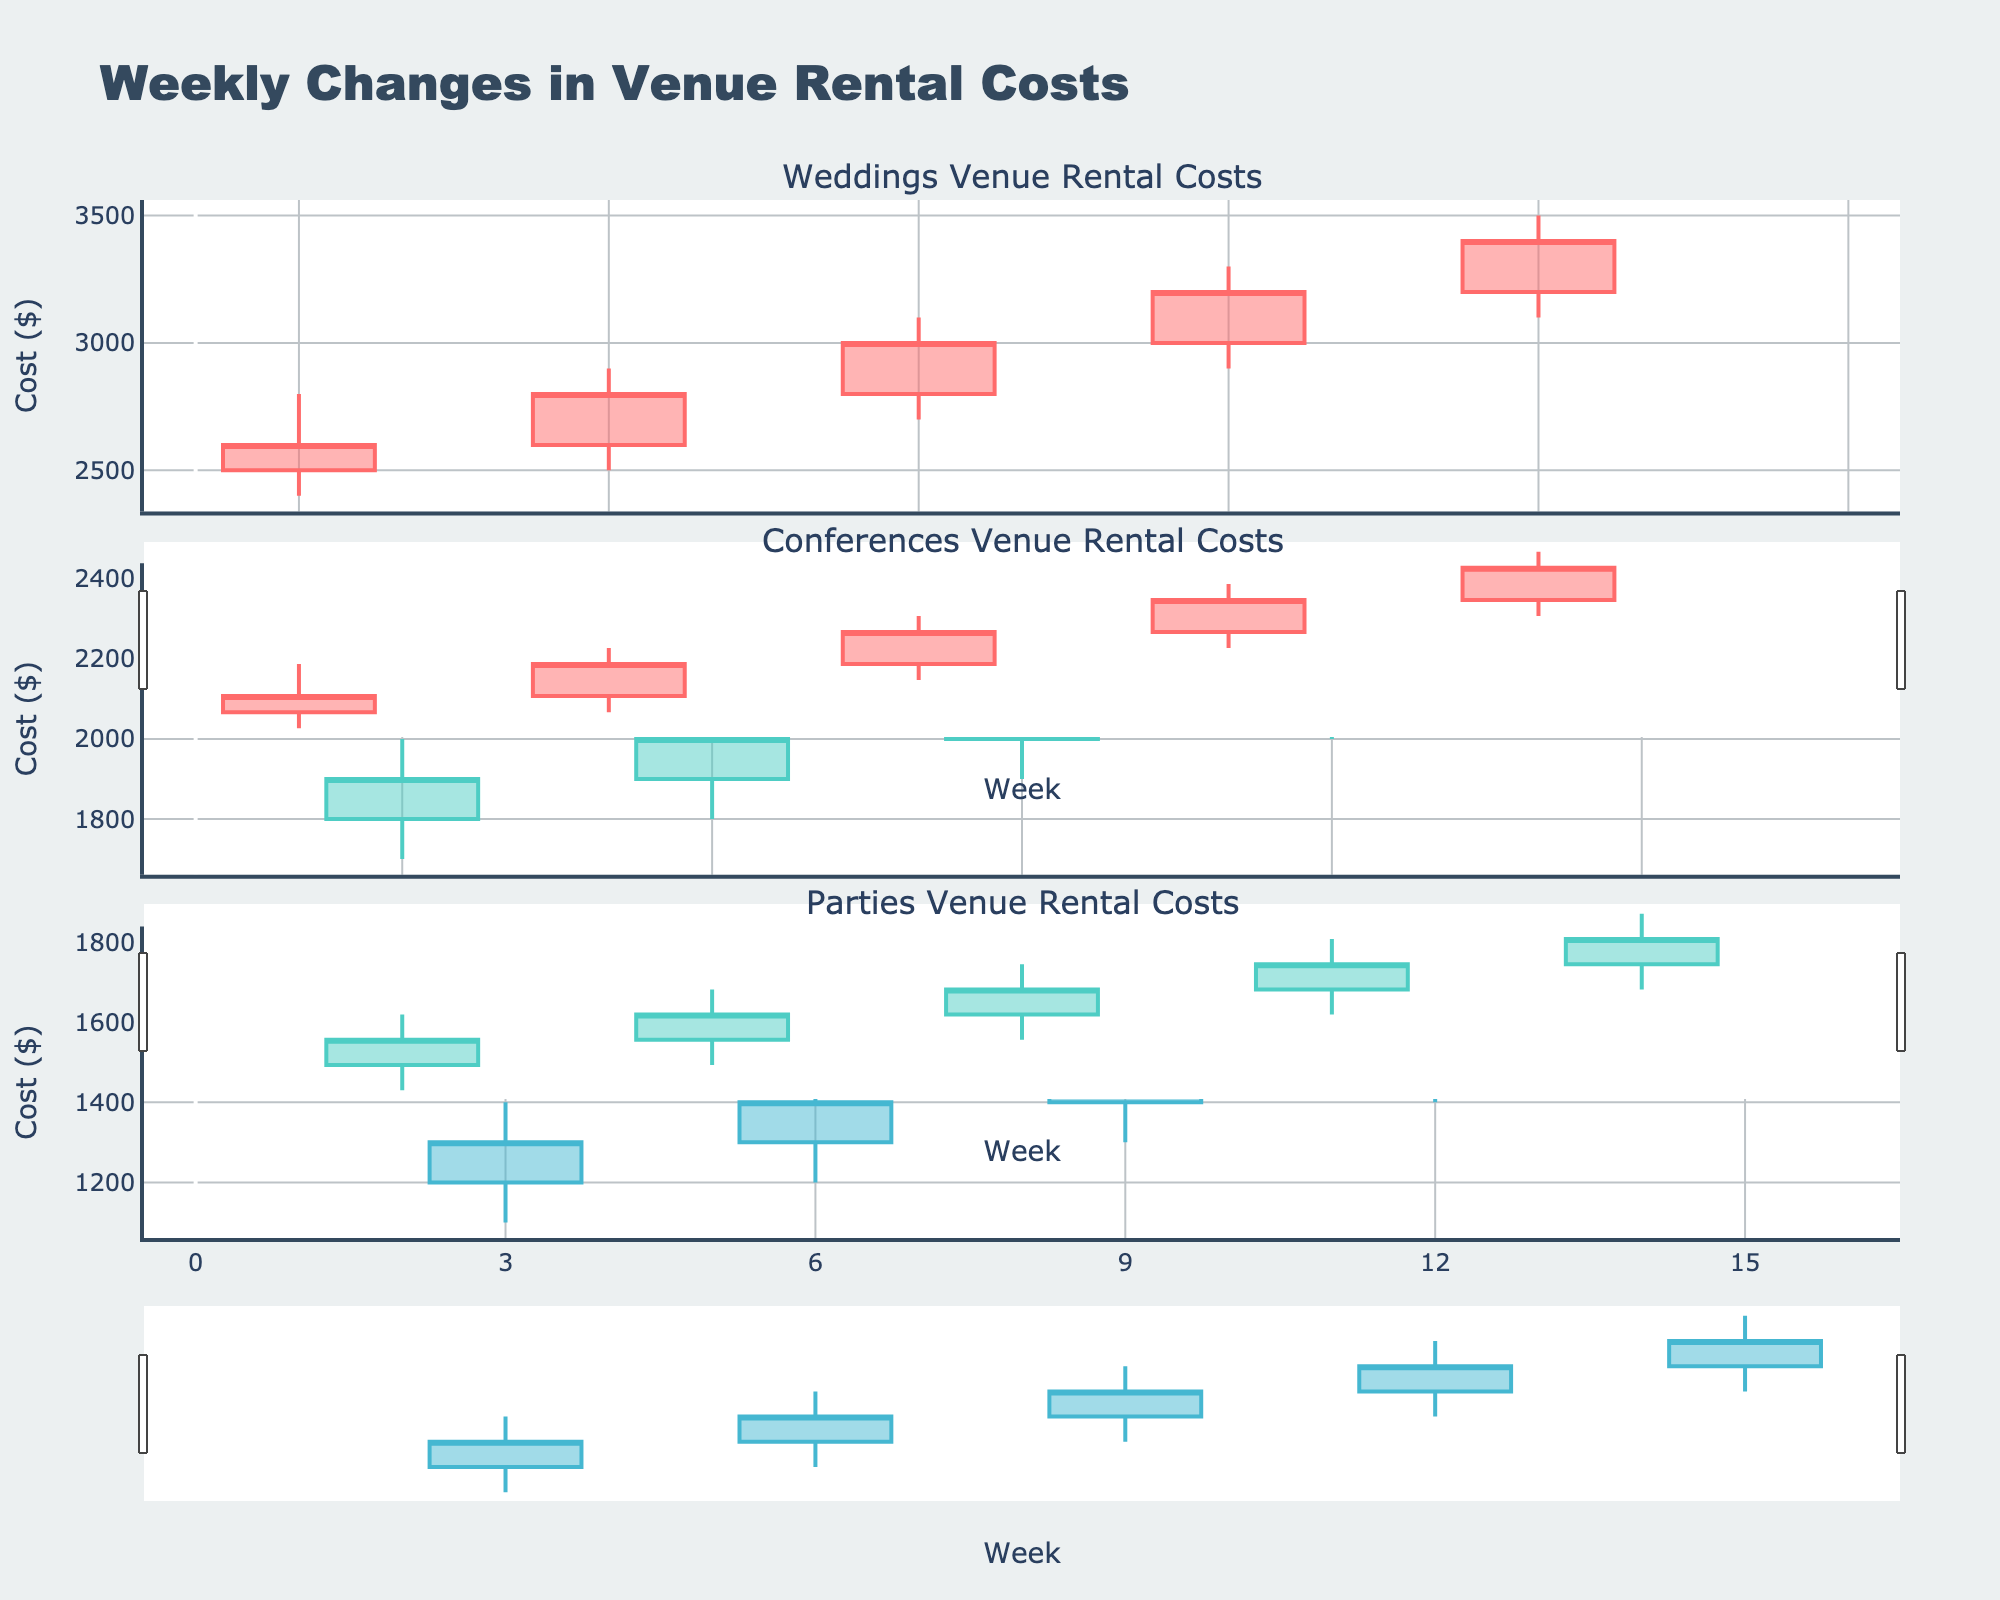Which event type has the highest closing cost in Week 5? To determine the highest closing cost in Week 5, look at the closing values for all event types in Week 5: Weddings (N/A), Conferences (2000), and Parties (1400). Conferences have the highest closing cost.
Answer: Conferences What is the average opening cost for Parties in weeks 3, 6, and 9? To find the average, first identify the opening costs for Parties in weeks 3 (1200), 6 (1300), and 9 (1400). Sum these values: (1200 + 1300 + 1400) = 3900, then divide by the number of weeks: 3900 / 3 = 1300.
Answer: 1300 During which week did Weddings experience the largest difference between their high and low costs? Calculate the difference for each week Weddings data: Week 1 (2800-2400=400), Week 4 (2900-2500=400), Week 7 (3100-2700=400), Week 10 (3300-2900=400), and Week 13 (3500-3100=400). All weeks have the same difference of 400.
Answer: Weeks 1, 4, 7, 10, and 13 Which event type had the highest increase in rental cost between the opening and closing values in Week 11? Examine the increase by calculating the difference between the opening and closing costs for Week 11: Weddings (N/A), Conferences (2200-2100=100), and Parties (N/A). Conferences had the highest increase.
Answer: Conferences What is the difference between the highest closing costs for Weddings and Conferences in any week? Identify the highest closing costs: Weddings (Week 13: 3400), Conferences (Week 14: 2300). Subtract the highest value for conferences from weddings: 3400 - 2300 = 1100.
Answer: 1100 What was the closing cost for Parties in Week 12? Look at the closing cost for Parties in Week 12: 1600.
Answer: 1600 How many weeks did the low cost for Conferences fall below 2000? Count the weeks where the low cost for Conferences is below 2000: Weeks 2 (1700), 5 (1800), 8 (1900), 11 (2000 exactly, not below). There are 3 such weeks.
Answer: 3 